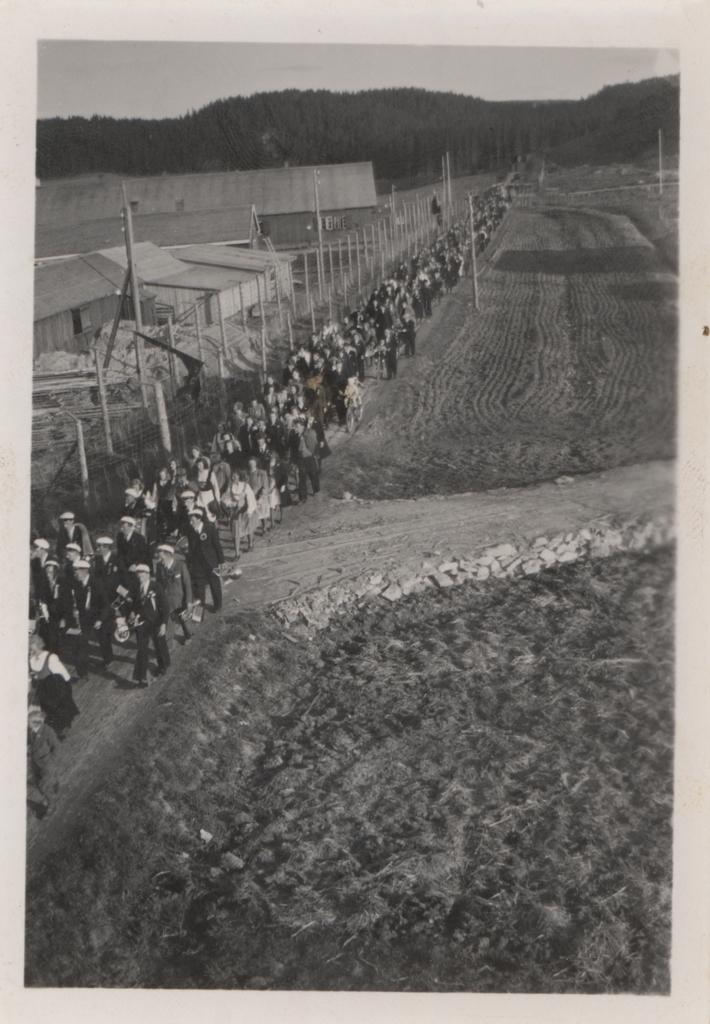What are the people in the image doing? The people in the image are standing on the road. What can be seen in the background of the image? There are buildings visible in the image. What is the color scheme of the image? The image is in black and white color. Is the boy in the image taking a test? There is no boy present in the image, and therefore no test can be observed. 